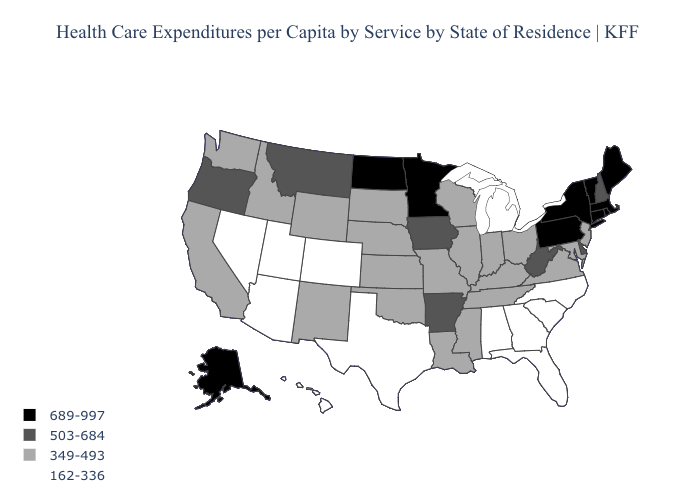What is the value of Kentucky?
Answer briefly. 349-493. Name the states that have a value in the range 689-997?
Quick response, please. Alaska, Connecticut, Maine, Massachusetts, Minnesota, New York, North Dakota, Pennsylvania, Rhode Island, Vermont. Does Florida have the highest value in the USA?
Short answer required. No. Is the legend a continuous bar?
Concise answer only. No. Among the states that border Alabama , which have the highest value?
Concise answer only. Mississippi, Tennessee. Name the states that have a value in the range 689-997?
Concise answer only. Alaska, Connecticut, Maine, Massachusetts, Minnesota, New York, North Dakota, Pennsylvania, Rhode Island, Vermont. What is the value of New Jersey?
Short answer required. 349-493. Name the states that have a value in the range 162-336?
Answer briefly. Alabama, Arizona, Colorado, Florida, Georgia, Hawaii, Michigan, Nevada, North Carolina, South Carolina, Texas, Utah. What is the value of South Carolina?
Short answer required. 162-336. Name the states that have a value in the range 689-997?
Give a very brief answer. Alaska, Connecticut, Maine, Massachusetts, Minnesota, New York, North Dakota, Pennsylvania, Rhode Island, Vermont. Name the states that have a value in the range 503-684?
Quick response, please. Arkansas, Delaware, Iowa, Montana, New Hampshire, Oregon, West Virginia. Among the states that border Utah , does Arizona have the lowest value?
Write a very short answer. Yes. Name the states that have a value in the range 503-684?
Write a very short answer. Arkansas, Delaware, Iowa, Montana, New Hampshire, Oregon, West Virginia. Name the states that have a value in the range 162-336?
Keep it brief. Alabama, Arizona, Colorado, Florida, Georgia, Hawaii, Michigan, Nevada, North Carolina, South Carolina, Texas, Utah. Which states have the lowest value in the Northeast?
Give a very brief answer. New Jersey. 